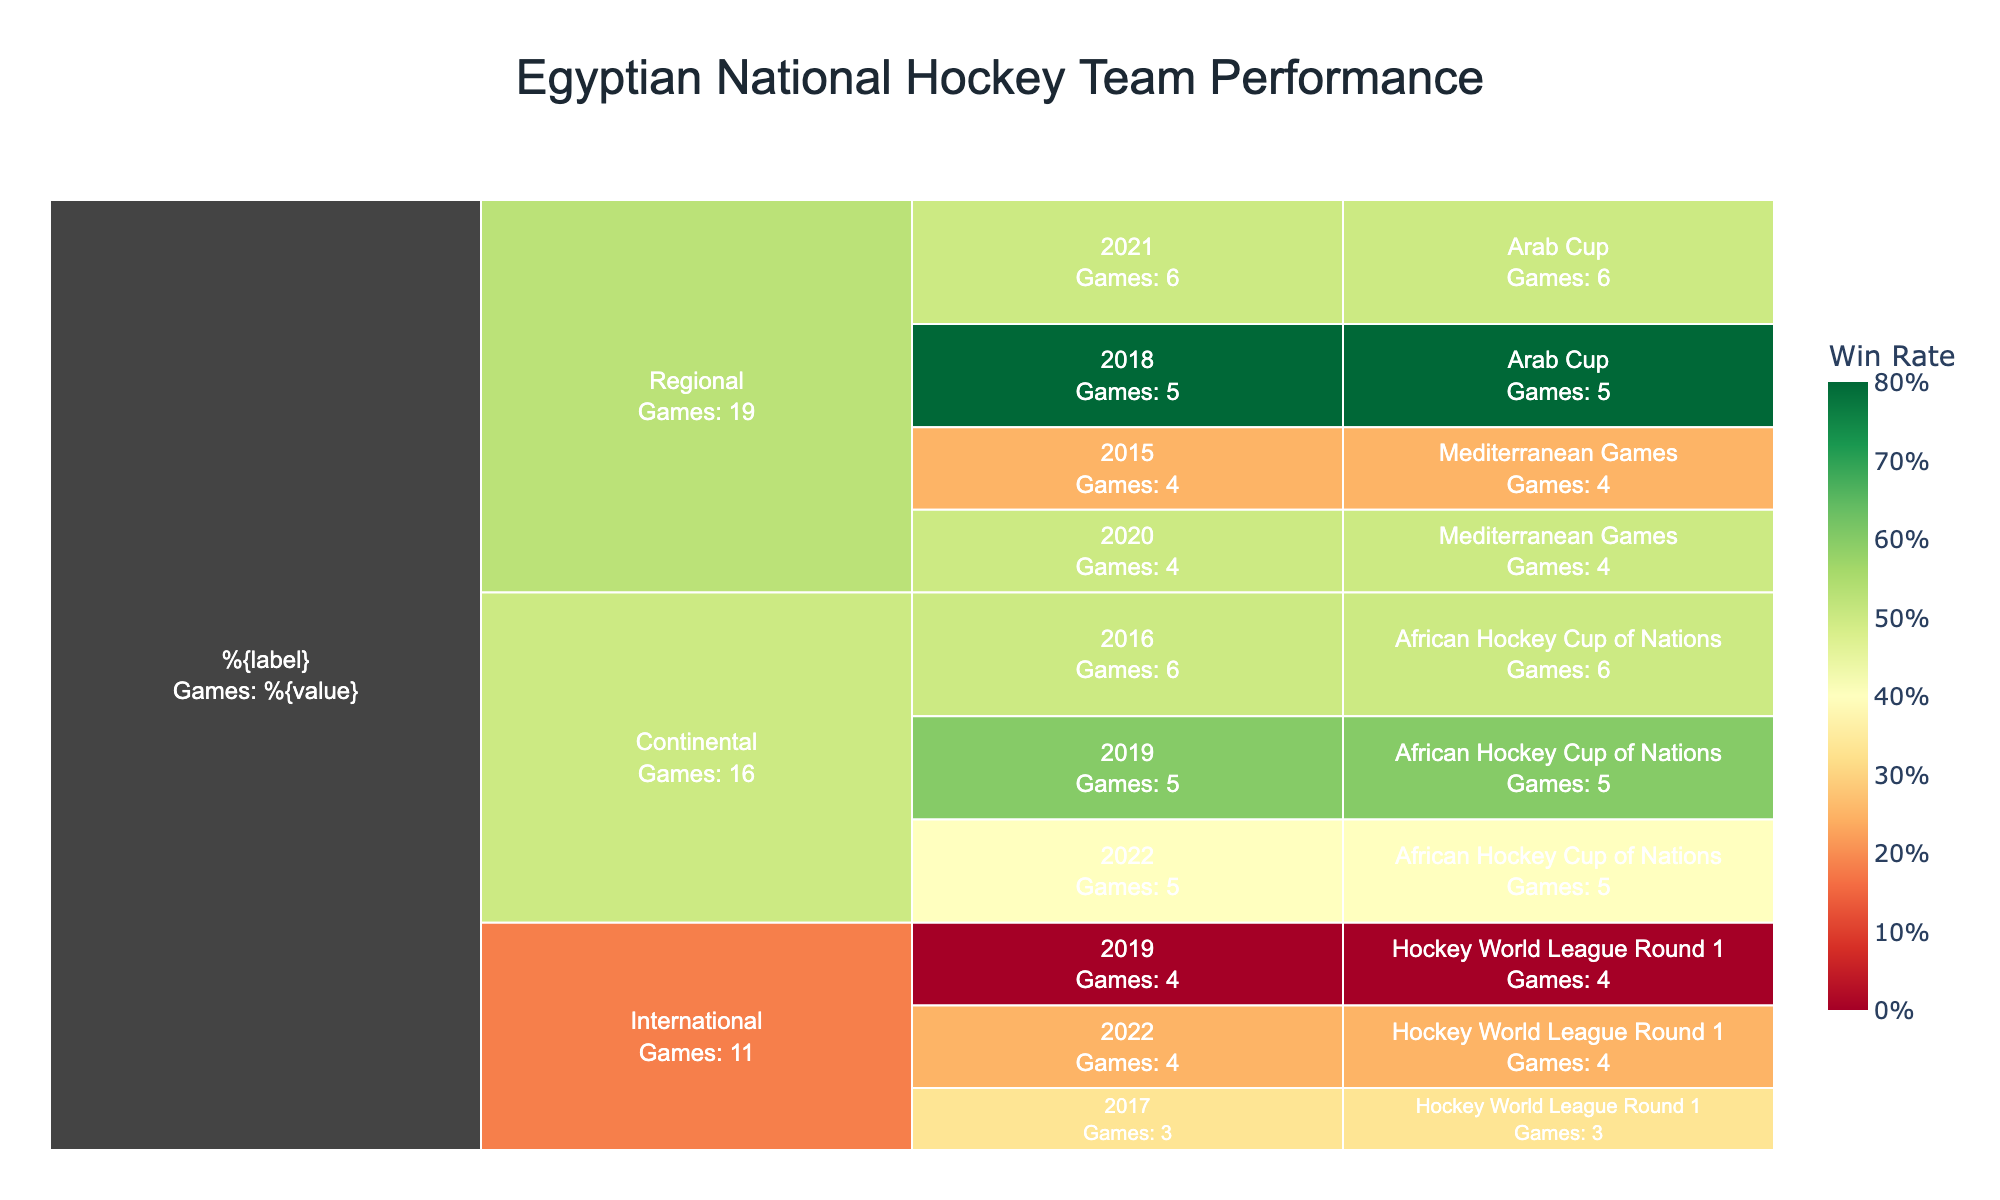What is the title of the figure? The title is usually shown at the top of the chart. It provides the main idea or topic of the figure. In this case, it is clearly stated as "Egyptian National Hockey Team Performance".
Answer: Egyptian National Hockey Team Performance How is the color used in the Icicle chart? The color in the Icicle chart represents the Win Rate of the Egyptian national hockey team, using a continuous color scale from red (low Win Rate) to green (high Win Rate).
Answer: It represents Win Rate Which competition had the highest Win Rate in 2021? By looking at the color coding in the chart and identifying the year 2021, we find that the Arab Cup had the highest Win Rate since it is the most green-colored section in 2021.
Answer: Arab Cup What was the win rate of the team in the 2022 African Hockey Cup of Nations? The information can be extracted by hovering over the respective segment in the chart, which shows that the win rate in the 2022 African Hockey Cup of Nations is displayed as a percentage.
Answer: 40% Which year showed the highest number of games played at the regional level? We observe the chart and look under the 'Regional' category. By comparing the segment sizes, we can see that the year with the largest segment represents the highest number of games played, which is in 2021.
Answer: 2021 Which year did the Egyptian national team participate in the most competitions? Look for the year that appears with multiple competitions across different levels. By analyzing the breakdown, we see that 2022 includes both the African Hockey Cup of Nations and Hockey World League Round 1, indicating active participation in multiple competitions.
Answer: 2022 Compare the win rate of the Egyptian team in the 2019 African Hockey Cup of Nations to the 2016 African Hockey Cup of Nations. Which year had a higher win rate? Check the color and hover text for both years in the African Hockey Cup of Nations section. The win rate is higher where the color is more green or by directly reading the percentages from the hover text. 2016 shows a 50% win rate while 2019 shows a 60% win rate.
Answer: 2019 What was the goal scoring efficiency (Goals per Game) in the 2018 Arab Cup? By hovering over the respective segment for the 2018 Arab Cup and noting the goals scored and games played, the chart provides Goals per Game directly in the hover text, which is 22 goals in 5 games.
Answer: 4.4 Which level shows the most consistent performance over the years in terms of win rate? Consistency can be judged by how uniform the color is across different years within the same level. By comparing the categories 'Continental', 'International', and 'Regional', we find that 'Regional' has relatively consistent shades, indicating steady performance.
Answer: Regional 